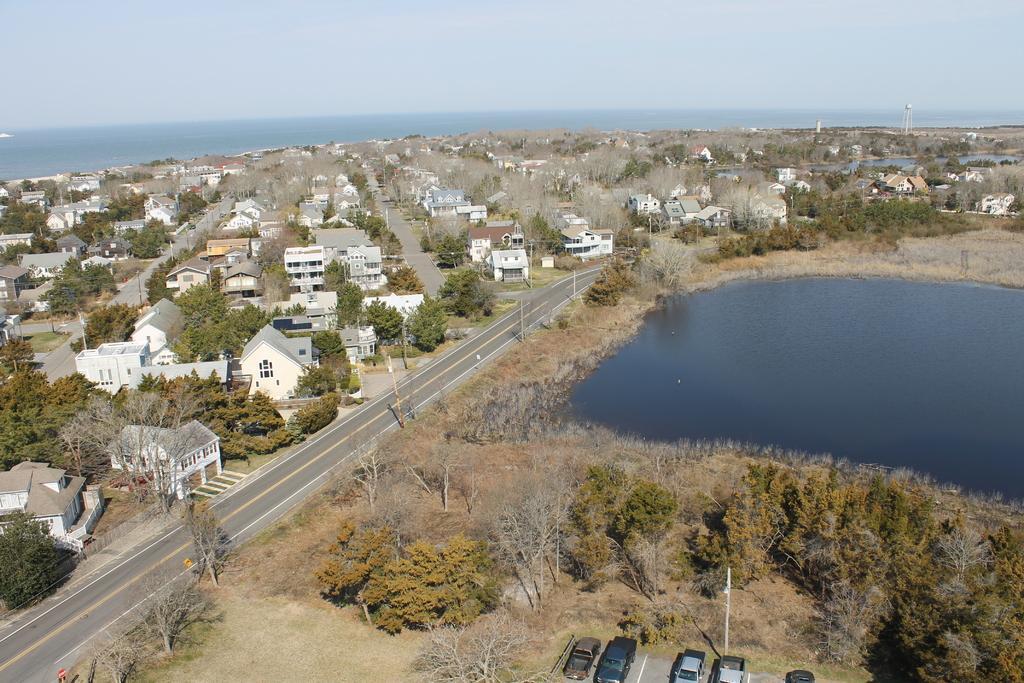Describe this image in one or two sentences. In this picture we can see the road, trees, water, buildings with windows, cars and in the background we can see the sky. 